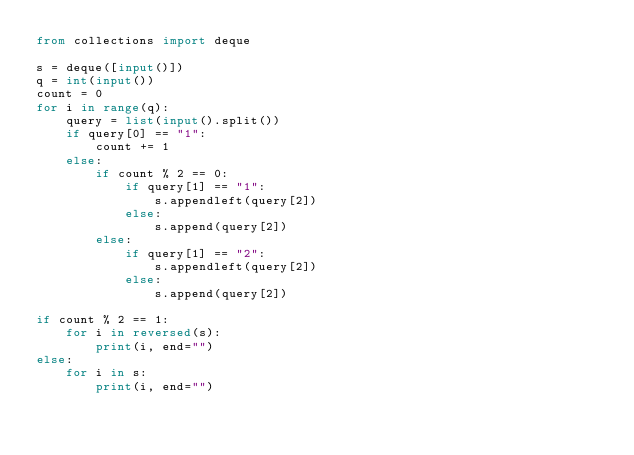<code> <loc_0><loc_0><loc_500><loc_500><_Python_>from collections import deque

s = deque([input()])
q = int(input())
count = 0
for i in range(q):
    query = list(input().split())
    if query[0] == "1":
        count += 1
    else:
        if count % 2 == 0:
            if query[1] == "1":
                s.appendleft(query[2])
            else:
                s.append(query[2])
        else:
            if query[1] == "2":
                s.appendleft(query[2])
            else:
                s.append(query[2])

if count % 2 == 1:
    for i in reversed(s):
        print(i, end="")
else:
    for i in s:
        print(i, end="")

</code> 